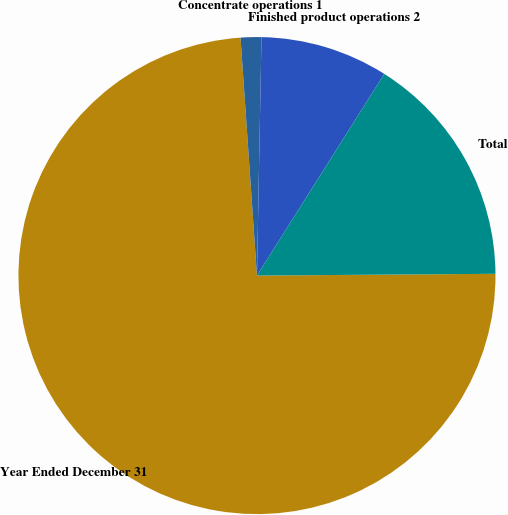Convert chart to OTSL. <chart><loc_0><loc_0><loc_500><loc_500><pie_chart><fcel>Year Ended December 31<fcel>Concentrate operations 1<fcel>Finished product operations 2<fcel>Total<nl><fcel>74.02%<fcel>1.4%<fcel>8.66%<fcel>15.92%<nl></chart> 